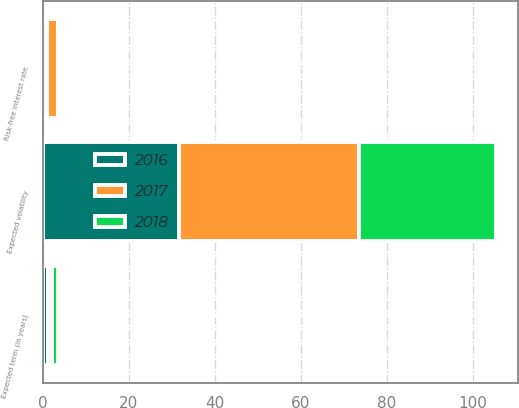Convert chart to OTSL. <chart><loc_0><loc_0><loc_500><loc_500><stacked_bar_chart><ecel><fcel>Expected term (in years)<fcel>Risk-free interest rate<fcel>Expected volatility<nl><fcel>2017<fcel>1.1<fcel>2.4<fcel>41.9<nl><fcel>2016<fcel>1.2<fcel>1.1<fcel>31.7<nl><fcel>2018<fcel>1.2<fcel>0.6<fcel>31.8<nl></chart> 